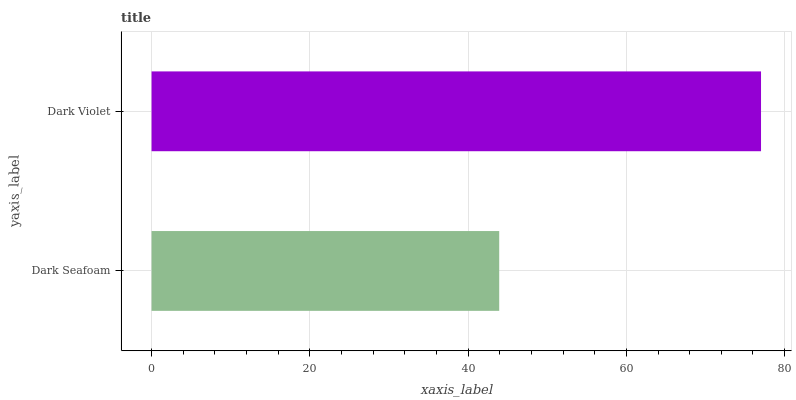Is Dark Seafoam the minimum?
Answer yes or no. Yes. Is Dark Violet the maximum?
Answer yes or no. Yes. Is Dark Violet the minimum?
Answer yes or no. No. Is Dark Violet greater than Dark Seafoam?
Answer yes or no. Yes. Is Dark Seafoam less than Dark Violet?
Answer yes or no. Yes. Is Dark Seafoam greater than Dark Violet?
Answer yes or no. No. Is Dark Violet less than Dark Seafoam?
Answer yes or no. No. Is Dark Violet the high median?
Answer yes or no. Yes. Is Dark Seafoam the low median?
Answer yes or no. Yes. Is Dark Seafoam the high median?
Answer yes or no. No. Is Dark Violet the low median?
Answer yes or no. No. 